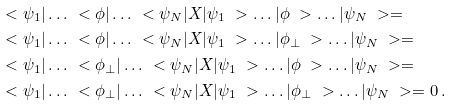Convert formula to latex. <formula><loc_0><loc_0><loc_500><loc_500>& \ < \psi _ { 1 } | \dots \ < \phi | \dots \ < \psi _ { N } | X | \psi _ { 1 } \ > \dots | \phi \ > \dots | \psi _ { N } \ > = \\ & \ < \psi _ { 1 } | \dots \ < \phi | \dots \ < \psi _ { N } | X | \psi _ { 1 } \ > \dots | \phi _ { \perp } \ > \dots | \psi _ { N } \ > = \\ & \ < \psi _ { 1 } | \dots \ < \phi _ { \perp } | \dots \ < \psi _ { N } | X | \psi _ { 1 } \ > \dots | \phi \ > \dots | \psi _ { N } \ > = \\ & \ < \psi _ { 1 } | \dots \ < \phi _ { \perp } | \dots \ < \psi _ { N } | X | \psi _ { 1 } \ > \dots | \phi _ { \perp } \ > \dots | \psi _ { N } \ > = 0 \, .</formula> 